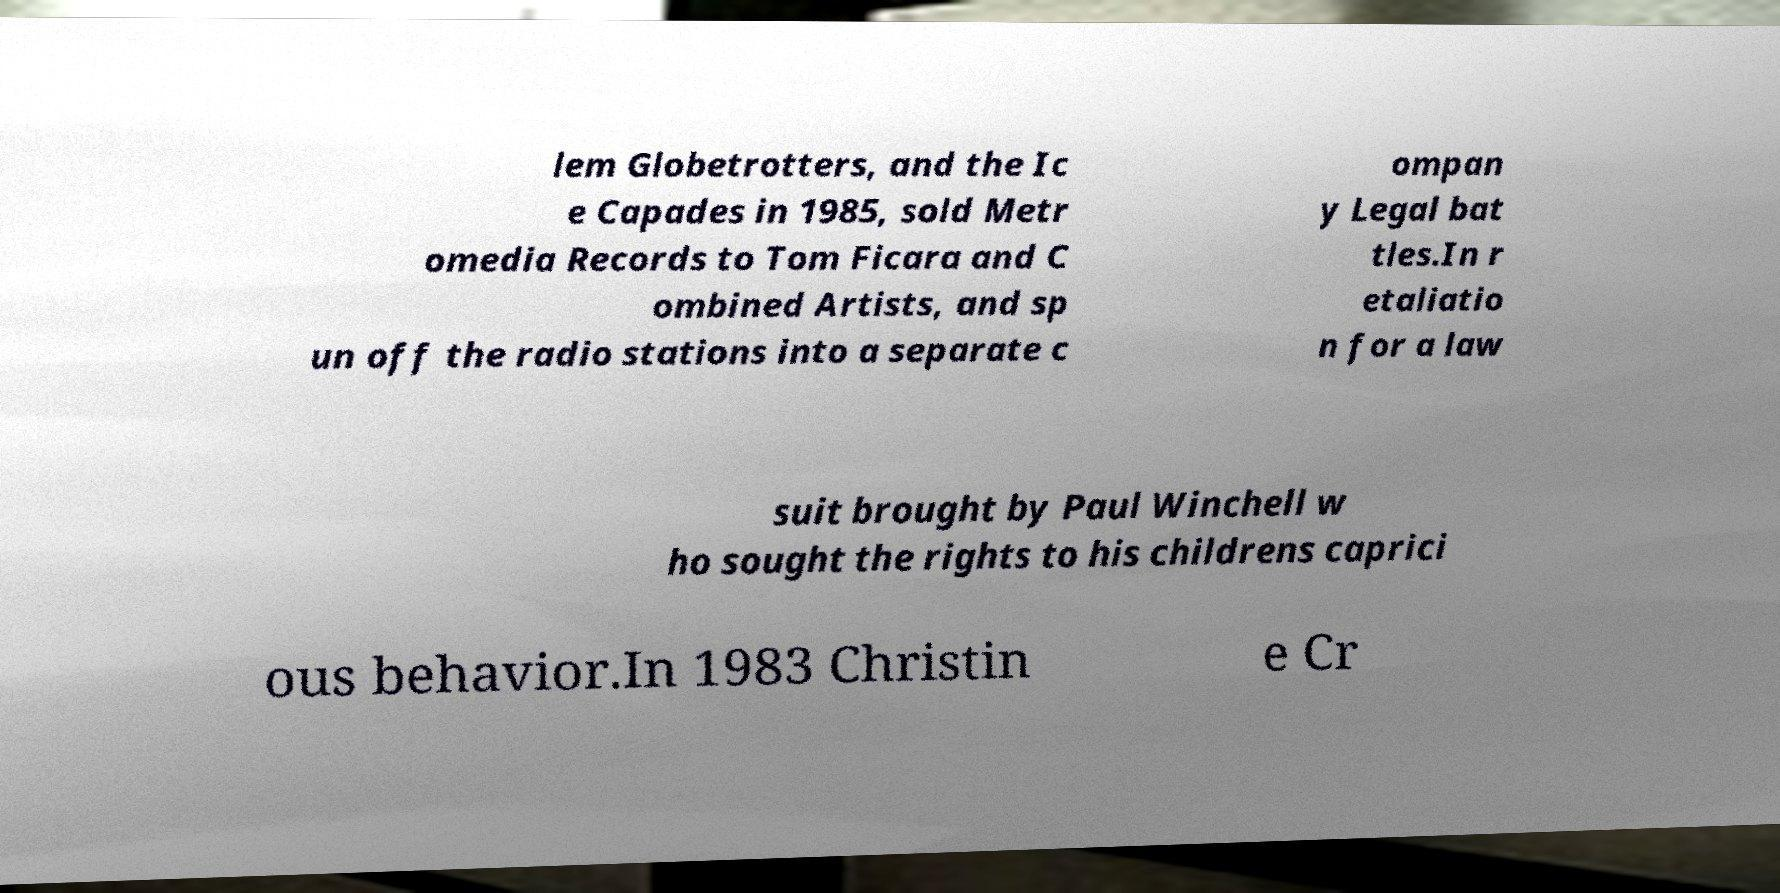Please read and relay the text visible in this image. What does it say? lem Globetrotters, and the Ic e Capades in 1985, sold Metr omedia Records to Tom Ficara and C ombined Artists, and sp un off the radio stations into a separate c ompan y Legal bat tles.In r etaliatio n for a law suit brought by Paul Winchell w ho sought the rights to his childrens caprici ous behavior.In 1983 Christin e Cr 